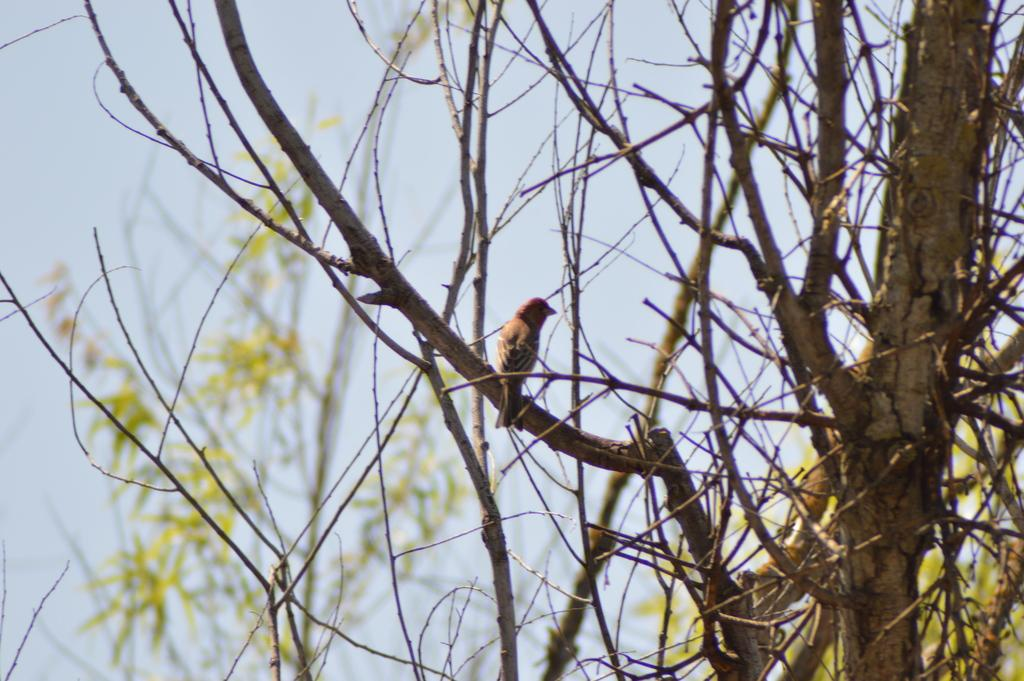What type of animal can be seen in the image? There is a bird in the image. Where is the bird located? The bird is sitting on a tree stem in the image. What type of plant is present in the image? There is a tree with stems in the image. What is visible at the top of the image? The sky is visible at the top of the image. What type of meat is the bird holding in its beak in the image? There is no meat present in the image; the bird is sitting on a tree stem. Is the bird playing a guitar in the image? There is no guitar present in the image; the bird is simply sitting on a tree stem. 